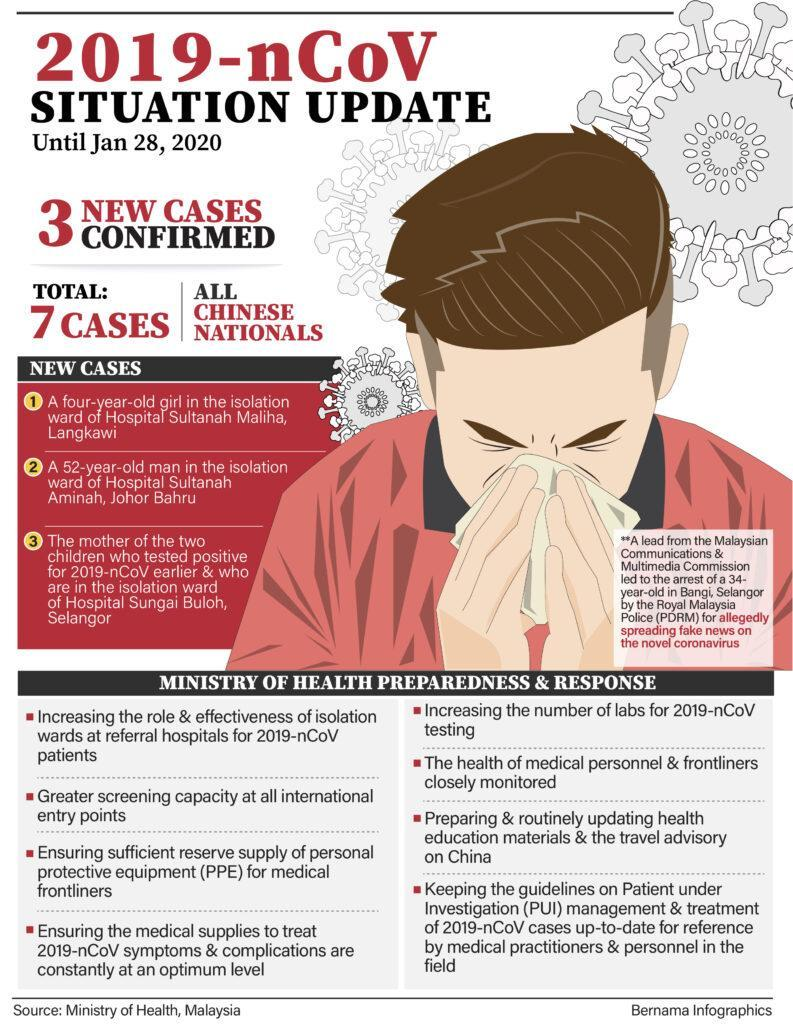What is the total number of cases?
Answer the question with a short phrase. 7 